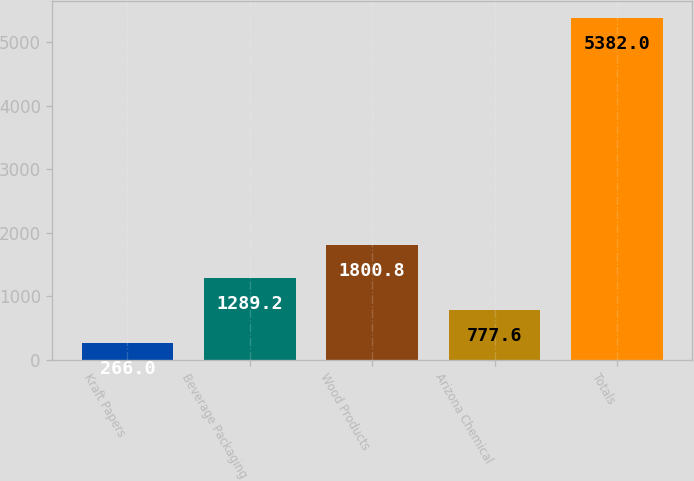Convert chart. <chart><loc_0><loc_0><loc_500><loc_500><bar_chart><fcel>Kraft Papers<fcel>Beverage Packaging<fcel>Wood Products<fcel>Arizona Chemical<fcel>Totals<nl><fcel>266<fcel>1289.2<fcel>1800.8<fcel>777.6<fcel>5382<nl></chart> 